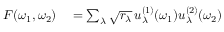<formula> <loc_0><loc_0><loc_500><loc_500>\begin{array} { r l } { F ( \omega _ { 1 } , \omega _ { 2 } ) } & = \sum _ { \lambda } \sqrt { r _ { \lambda } } \, u _ { \lambda } ^ { ( 1 ) } ( \omega _ { 1 } ) u _ { \lambda } ^ { ( 2 ) } ( \omega _ { 2 } ) } \end{array}</formula> 